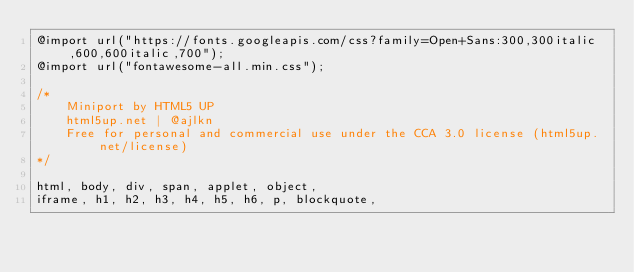<code> <loc_0><loc_0><loc_500><loc_500><_CSS_>@import url("https://fonts.googleapis.com/css?family=Open+Sans:300,300italic,600,600italic,700");
@import url("fontawesome-all.min.css");

/*
	Miniport by HTML5 UP
	html5up.net | @ajlkn
	Free for personal and commercial use under the CCA 3.0 license (html5up.net/license)
*/

html, body, div, span, applet, object,
iframe, h1, h2, h3, h4, h5, h6, p, blockquote,</code> 